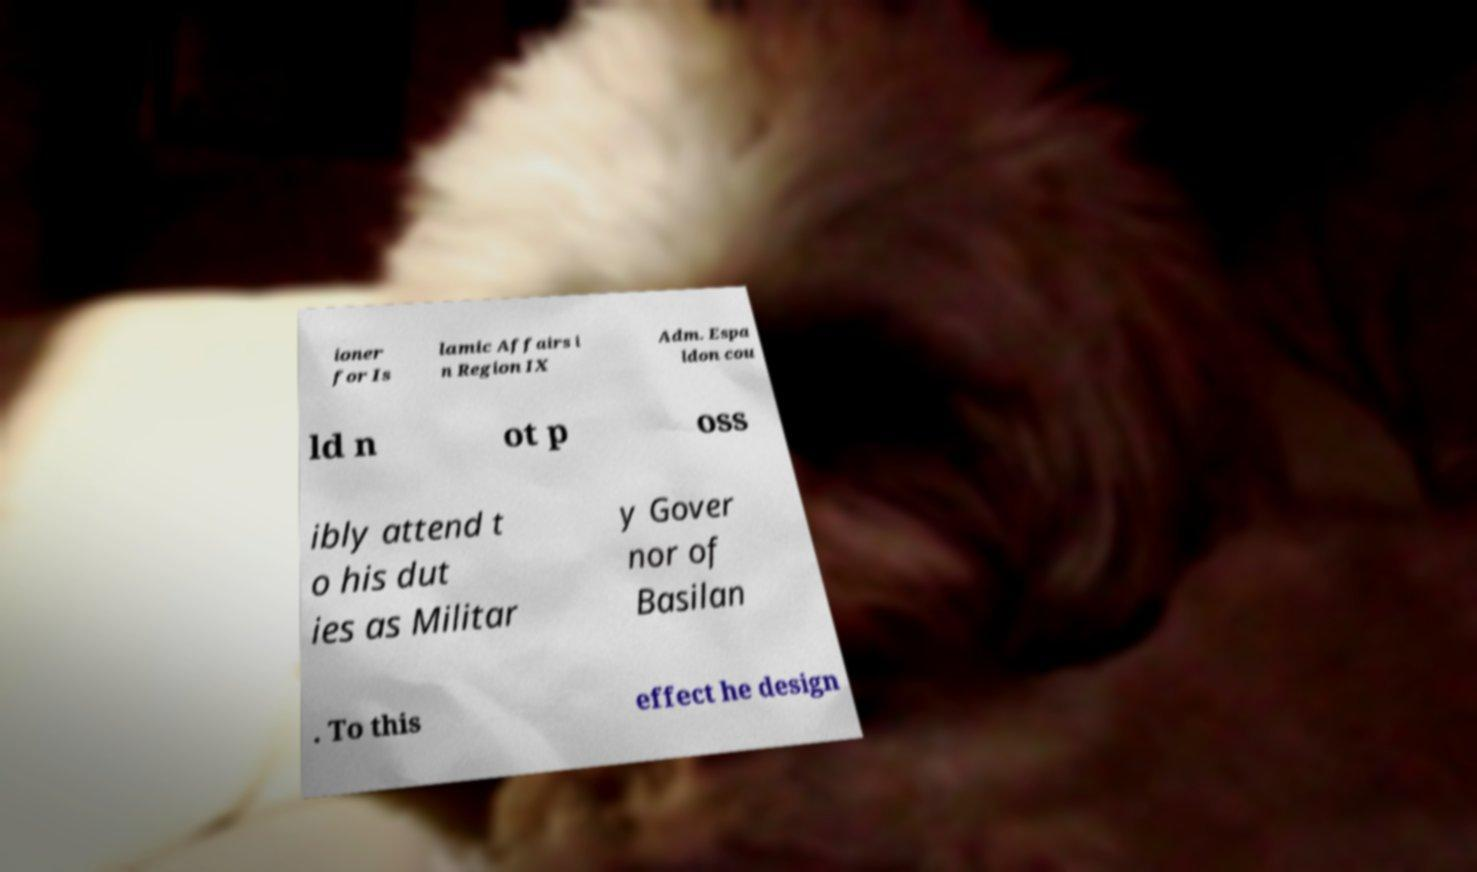What messages or text are displayed in this image? I need them in a readable, typed format. ioner for Is lamic Affairs i n Region IX Adm. Espa ldon cou ld n ot p oss ibly attend t o his dut ies as Militar y Gover nor of Basilan . To this effect he design 